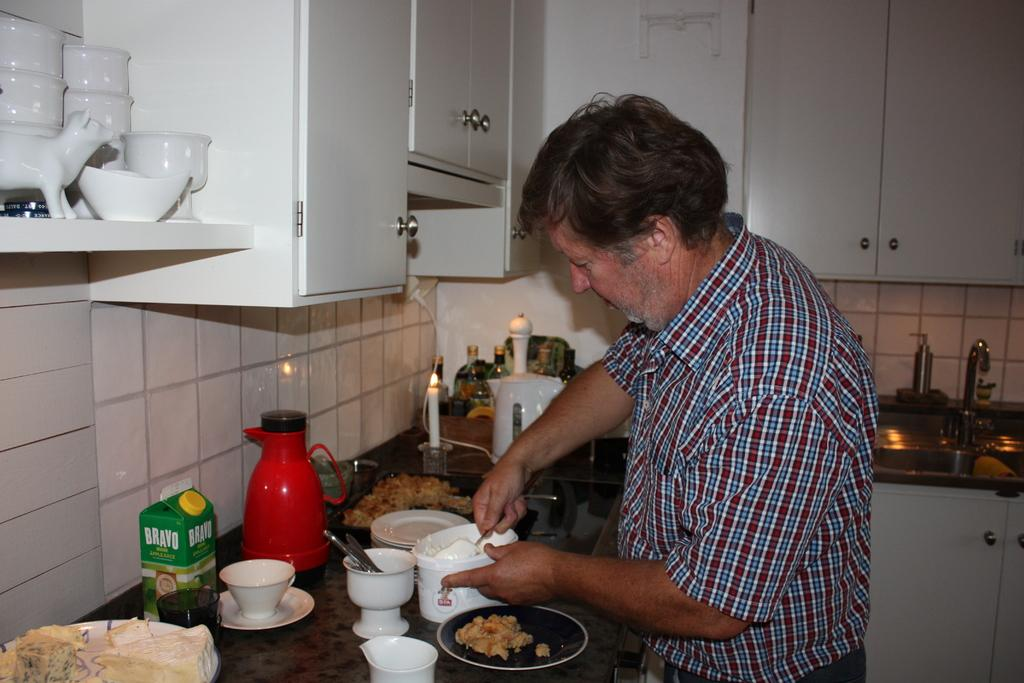<image>
Create a compact narrative representing the image presented. man preparing a recipe using bravo milk as an ingredent 